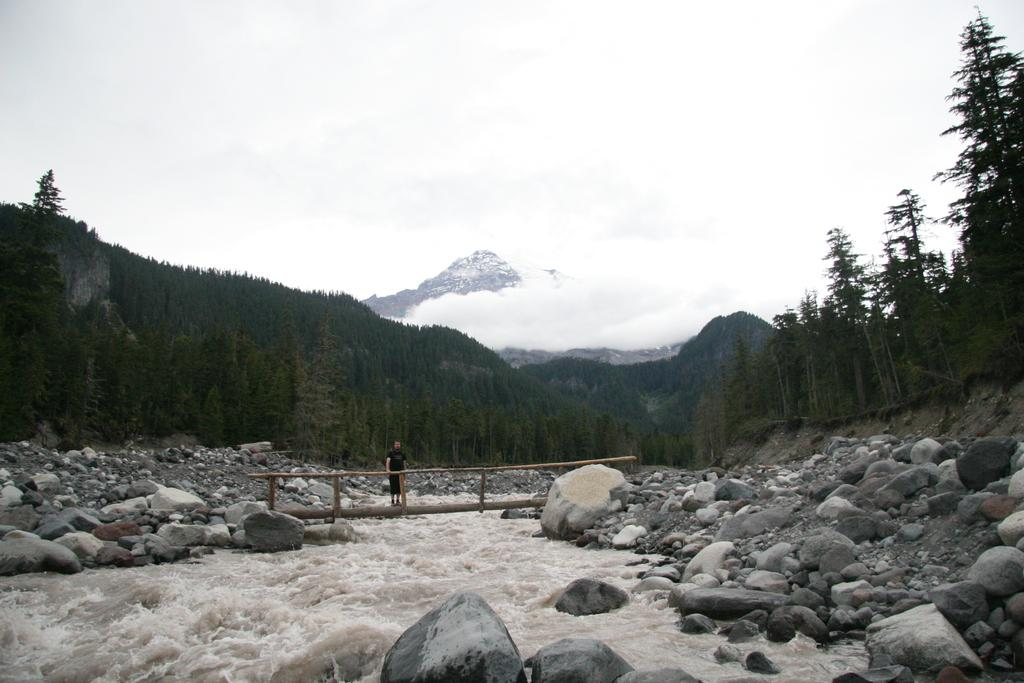What is the main feature in the center of the image? There is water in the center of the image. What other elements can be seen in the image? There are rocks, a person standing on a bridge, trees, mountains, and the sky visible in the background. What type of sheet is being used by the army in the image? There is no army or sheet present in the image. How many forks can be seen in the image? There are no forks present in the image. 